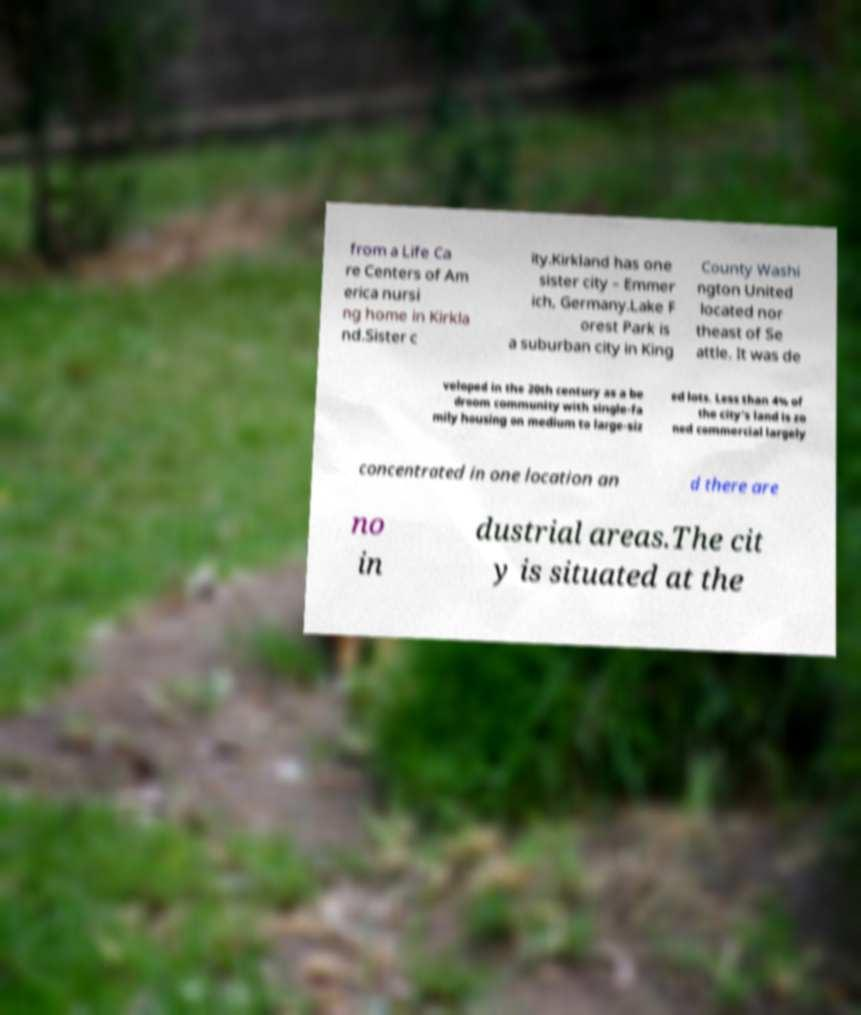Can you accurately transcribe the text from the provided image for me? from a Life Ca re Centers of Am erica nursi ng home in Kirkla nd.Sister c ity.Kirkland has one sister city – Emmer ich, Germany.Lake F orest Park is a suburban city in King County Washi ngton United located nor theast of Se attle. It was de veloped in the 20th century as a be droom community with single-fa mily housing on medium to large-siz ed lots. Less than 4% of the city's land is zo ned commercial largely concentrated in one location an d there are no in dustrial areas.The cit y is situated at the 